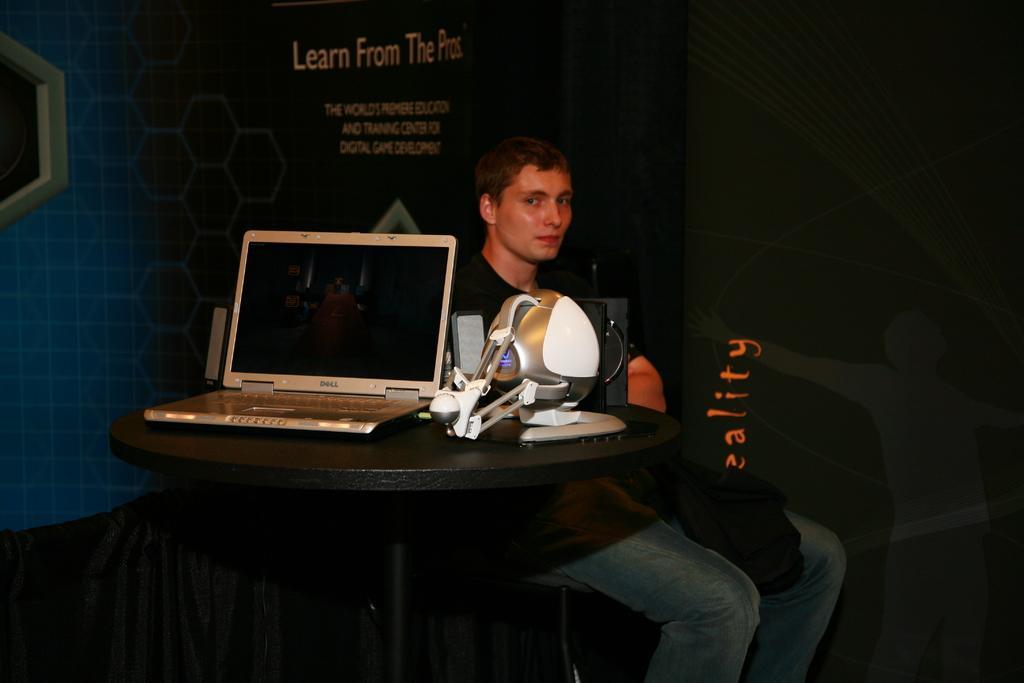Please provide a concise description of this image. In front of the image there is a table. On the table there is a laptop, speaker and some other things. Behind the table there is a man sitting. Behind the man there is a banner with text on it. 